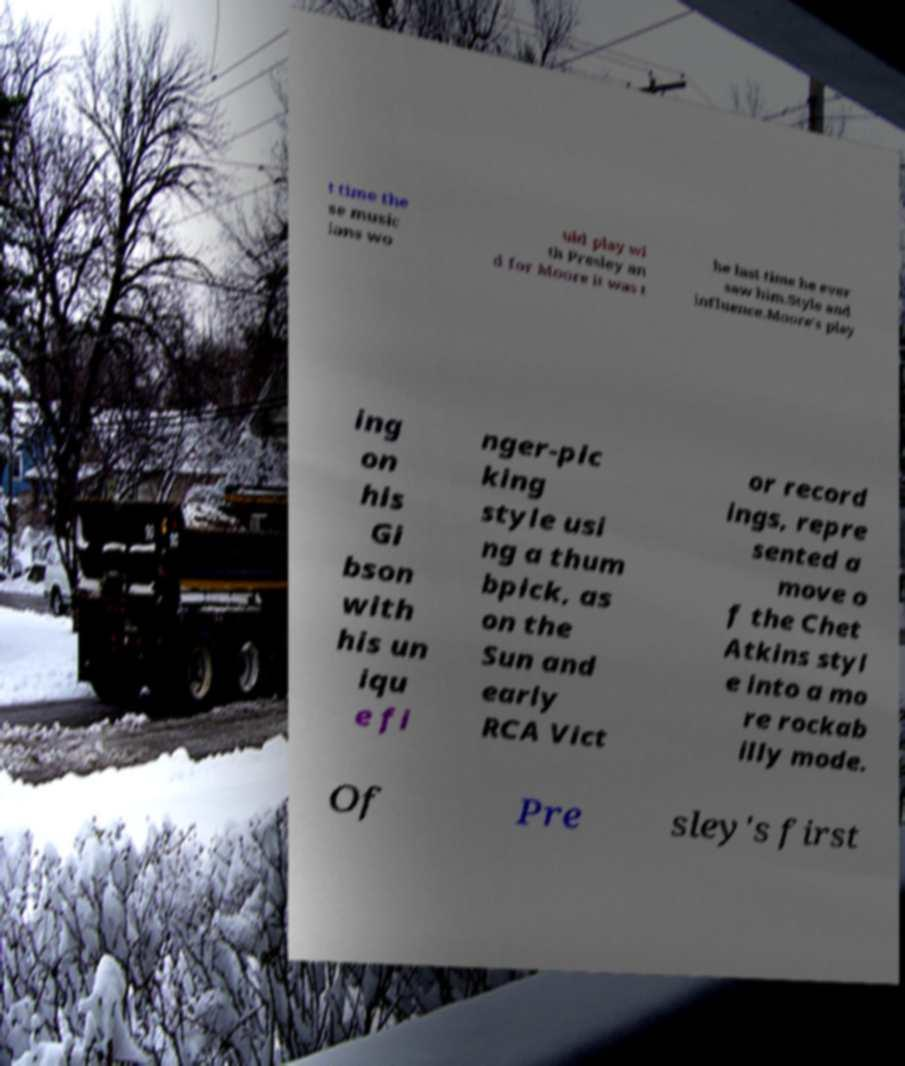What messages or text are displayed in this image? I need them in a readable, typed format. t time the se music ians wo uld play wi th Presley an d for Moore it was t he last time he ever saw him.Style and influence.Moore's play ing on his Gi bson with his un iqu e fi nger-pic king style usi ng a thum bpick, as on the Sun and early RCA Vict or record ings, repre sented a move o f the Chet Atkins styl e into a mo re rockab illy mode. Of Pre sley's first 